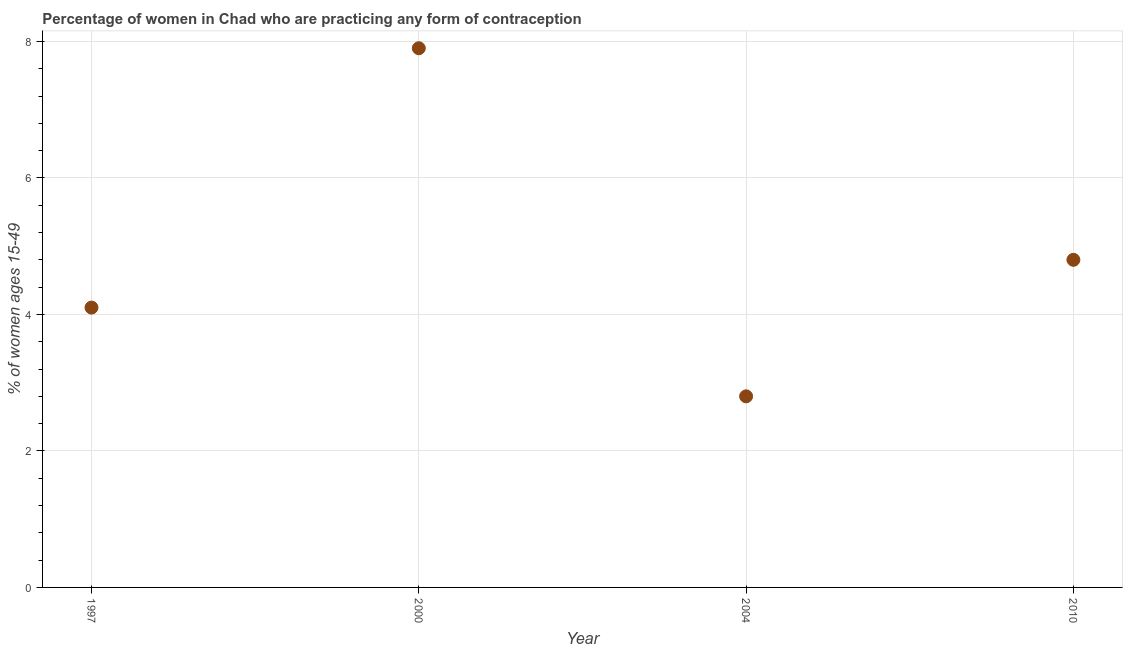Across all years, what is the minimum contraceptive prevalence?
Your answer should be very brief. 2.8. In which year was the contraceptive prevalence maximum?
Provide a succinct answer. 2000. What is the sum of the contraceptive prevalence?
Provide a succinct answer. 19.6. What is the difference between the contraceptive prevalence in 1997 and 2000?
Offer a very short reply. -3.8. What is the median contraceptive prevalence?
Provide a short and direct response. 4.45. In how many years, is the contraceptive prevalence greater than 3.6 %?
Make the answer very short. 3. What is the ratio of the contraceptive prevalence in 2000 to that in 2010?
Offer a terse response. 1.65. Is the contraceptive prevalence in 1997 less than that in 2004?
Make the answer very short. No. Is the difference between the contraceptive prevalence in 1997 and 2010 greater than the difference between any two years?
Make the answer very short. No. What is the difference between the highest and the second highest contraceptive prevalence?
Offer a very short reply. 3.1. Is the sum of the contraceptive prevalence in 2000 and 2010 greater than the maximum contraceptive prevalence across all years?
Give a very brief answer. Yes. What is the difference between the highest and the lowest contraceptive prevalence?
Ensure brevity in your answer.  5.1. How many dotlines are there?
Provide a succinct answer. 1. How many years are there in the graph?
Keep it short and to the point. 4. Does the graph contain grids?
Your answer should be very brief. Yes. What is the title of the graph?
Your answer should be compact. Percentage of women in Chad who are practicing any form of contraception. What is the label or title of the X-axis?
Provide a short and direct response. Year. What is the label or title of the Y-axis?
Your response must be concise. % of women ages 15-49. What is the % of women ages 15-49 in 1997?
Provide a short and direct response. 4.1. What is the % of women ages 15-49 in 2010?
Make the answer very short. 4.8. What is the difference between the % of women ages 15-49 in 1997 and 2000?
Offer a terse response. -3.8. What is the difference between the % of women ages 15-49 in 1997 and 2010?
Provide a succinct answer. -0.7. What is the difference between the % of women ages 15-49 in 2000 and 2004?
Your answer should be very brief. 5.1. What is the difference between the % of women ages 15-49 in 2000 and 2010?
Your answer should be very brief. 3.1. What is the difference between the % of women ages 15-49 in 2004 and 2010?
Give a very brief answer. -2. What is the ratio of the % of women ages 15-49 in 1997 to that in 2000?
Provide a short and direct response. 0.52. What is the ratio of the % of women ages 15-49 in 1997 to that in 2004?
Offer a terse response. 1.46. What is the ratio of the % of women ages 15-49 in 1997 to that in 2010?
Make the answer very short. 0.85. What is the ratio of the % of women ages 15-49 in 2000 to that in 2004?
Ensure brevity in your answer.  2.82. What is the ratio of the % of women ages 15-49 in 2000 to that in 2010?
Your answer should be very brief. 1.65. What is the ratio of the % of women ages 15-49 in 2004 to that in 2010?
Your answer should be very brief. 0.58. 